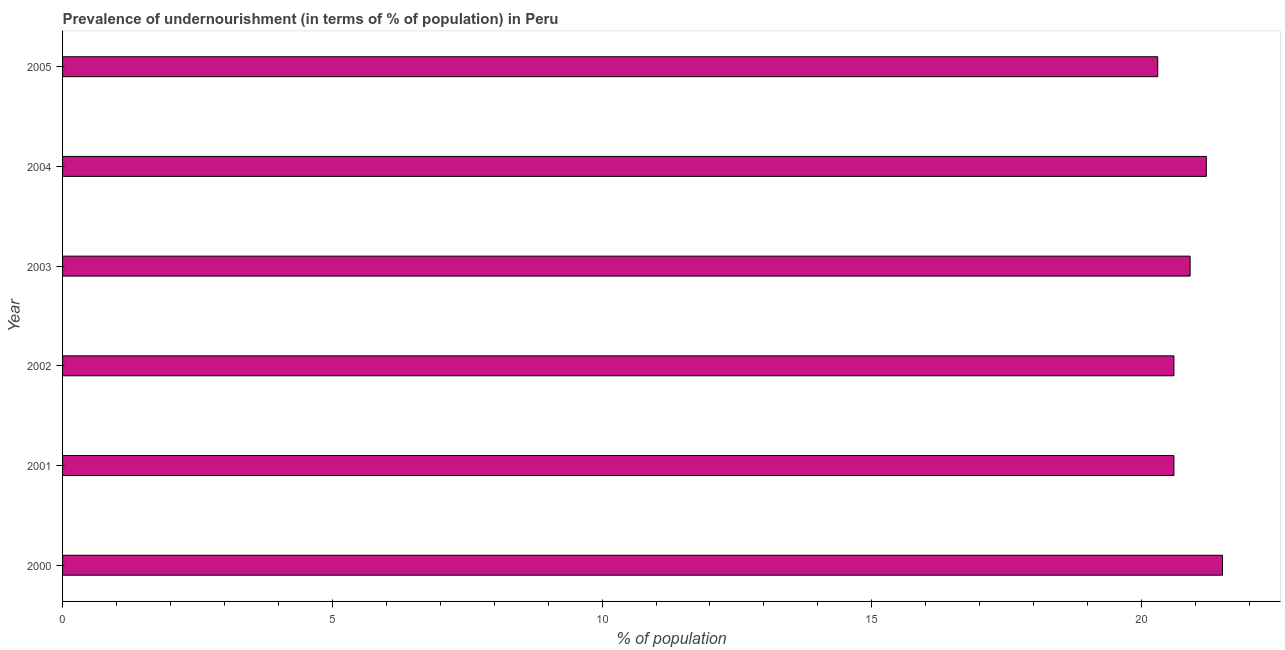Does the graph contain grids?
Provide a succinct answer. No. What is the title of the graph?
Your answer should be very brief. Prevalence of undernourishment (in terms of % of population) in Peru. What is the label or title of the X-axis?
Offer a very short reply. % of population. What is the label or title of the Y-axis?
Your response must be concise. Year. What is the percentage of undernourished population in 2004?
Offer a terse response. 21.2. Across all years, what is the minimum percentage of undernourished population?
Offer a terse response. 20.3. In which year was the percentage of undernourished population maximum?
Ensure brevity in your answer.  2000. In which year was the percentage of undernourished population minimum?
Offer a terse response. 2005. What is the sum of the percentage of undernourished population?
Offer a terse response. 125.1. What is the average percentage of undernourished population per year?
Provide a succinct answer. 20.85. What is the median percentage of undernourished population?
Make the answer very short. 20.75. Do a majority of the years between 2003 and 2001 (inclusive) have percentage of undernourished population greater than 14 %?
Your response must be concise. Yes. What is the difference between the highest and the second highest percentage of undernourished population?
Provide a short and direct response. 0.3. Is the sum of the percentage of undernourished population in 2000 and 2001 greater than the maximum percentage of undernourished population across all years?
Make the answer very short. Yes. Are the values on the major ticks of X-axis written in scientific E-notation?
Give a very brief answer. No. What is the % of population in 2001?
Provide a succinct answer. 20.6. What is the % of population of 2002?
Keep it short and to the point. 20.6. What is the % of population in 2003?
Your answer should be compact. 20.9. What is the % of population in 2004?
Provide a short and direct response. 21.2. What is the % of population in 2005?
Your answer should be compact. 20.3. What is the difference between the % of population in 2000 and 2003?
Offer a terse response. 0.6. What is the difference between the % of population in 2000 and 2004?
Keep it short and to the point. 0.3. What is the difference between the % of population in 2001 and 2002?
Make the answer very short. 0. What is the difference between the % of population in 2001 and 2005?
Offer a terse response. 0.3. What is the difference between the % of population in 2003 and 2005?
Keep it short and to the point. 0.6. What is the ratio of the % of population in 2000 to that in 2001?
Give a very brief answer. 1.04. What is the ratio of the % of population in 2000 to that in 2002?
Your answer should be very brief. 1.04. What is the ratio of the % of population in 2000 to that in 2003?
Ensure brevity in your answer.  1.03. What is the ratio of the % of population in 2000 to that in 2005?
Your response must be concise. 1.06. What is the ratio of the % of population in 2001 to that in 2003?
Offer a terse response. 0.99. What is the ratio of the % of population in 2001 to that in 2005?
Your answer should be very brief. 1.01. What is the ratio of the % of population in 2002 to that in 2003?
Provide a short and direct response. 0.99. What is the ratio of the % of population in 2002 to that in 2004?
Make the answer very short. 0.97. What is the ratio of the % of population in 2002 to that in 2005?
Ensure brevity in your answer.  1.01. What is the ratio of the % of population in 2003 to that in 2004?
Your answer should be very brief. 0.99. What is the ratio of the % of population in 2004 to that in 2005?
Your answer should be very brief. 1.04. 